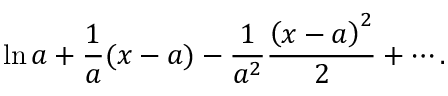<formula> <loc_0><loc_0><loc_500><loc_500>\ln a + { \frac { 1 } { a } } ( x - a ) - { \frac { 1 } { a ^ { 2 } } } { \frac { \left ( x - a \right ) ^ { 2 } } { 2 } } + \cdots .</formula> 